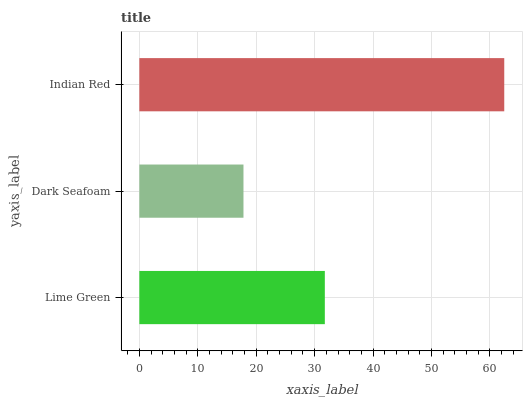Is Dark Seafoam the minimum?
Answer yes or no. Yes. Is Indian Red the maximum?
Answer yes or no. Yes. Is Indian Red the minimum?
Answer yes or no. No. Is Dark Seafoam the maximum?
Answer yes or no. No. Is Indian Red greater than Dark Seafoam?
Answer yes or no. Yes. Is Dark Seafoam less than Indian Red?
Answer yes or no. Yes. Is Dark Seafoam greater than Indian Red?
Answer yes or no. No. Is Indian Red less than Dark Seafoam?
Answer yes or no. No. Is Lime Green the high median?
Answer yes or no. Yes. Is Lime Green the low median?
Answer yes or no. Yes. Is Dark Seafoam the high median?
Answer yes or no. No. Is Dark Seafoam the low median?
Answer yes or no. No. 